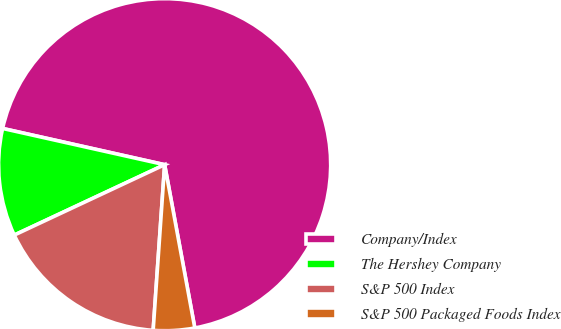Convert chart. <chart><loc_0><loc_0><loc_500><loc_500><pie_chart><fcel>Company/Index<fcel>The Hershey Company<fcel>S&P 500 Index<fcel>S&P 500 Packaged Foods Index<nl><fcel>68.59%<fcel>10.47%<fcel>16.93%<fcel>4.01%<nl></chart> 